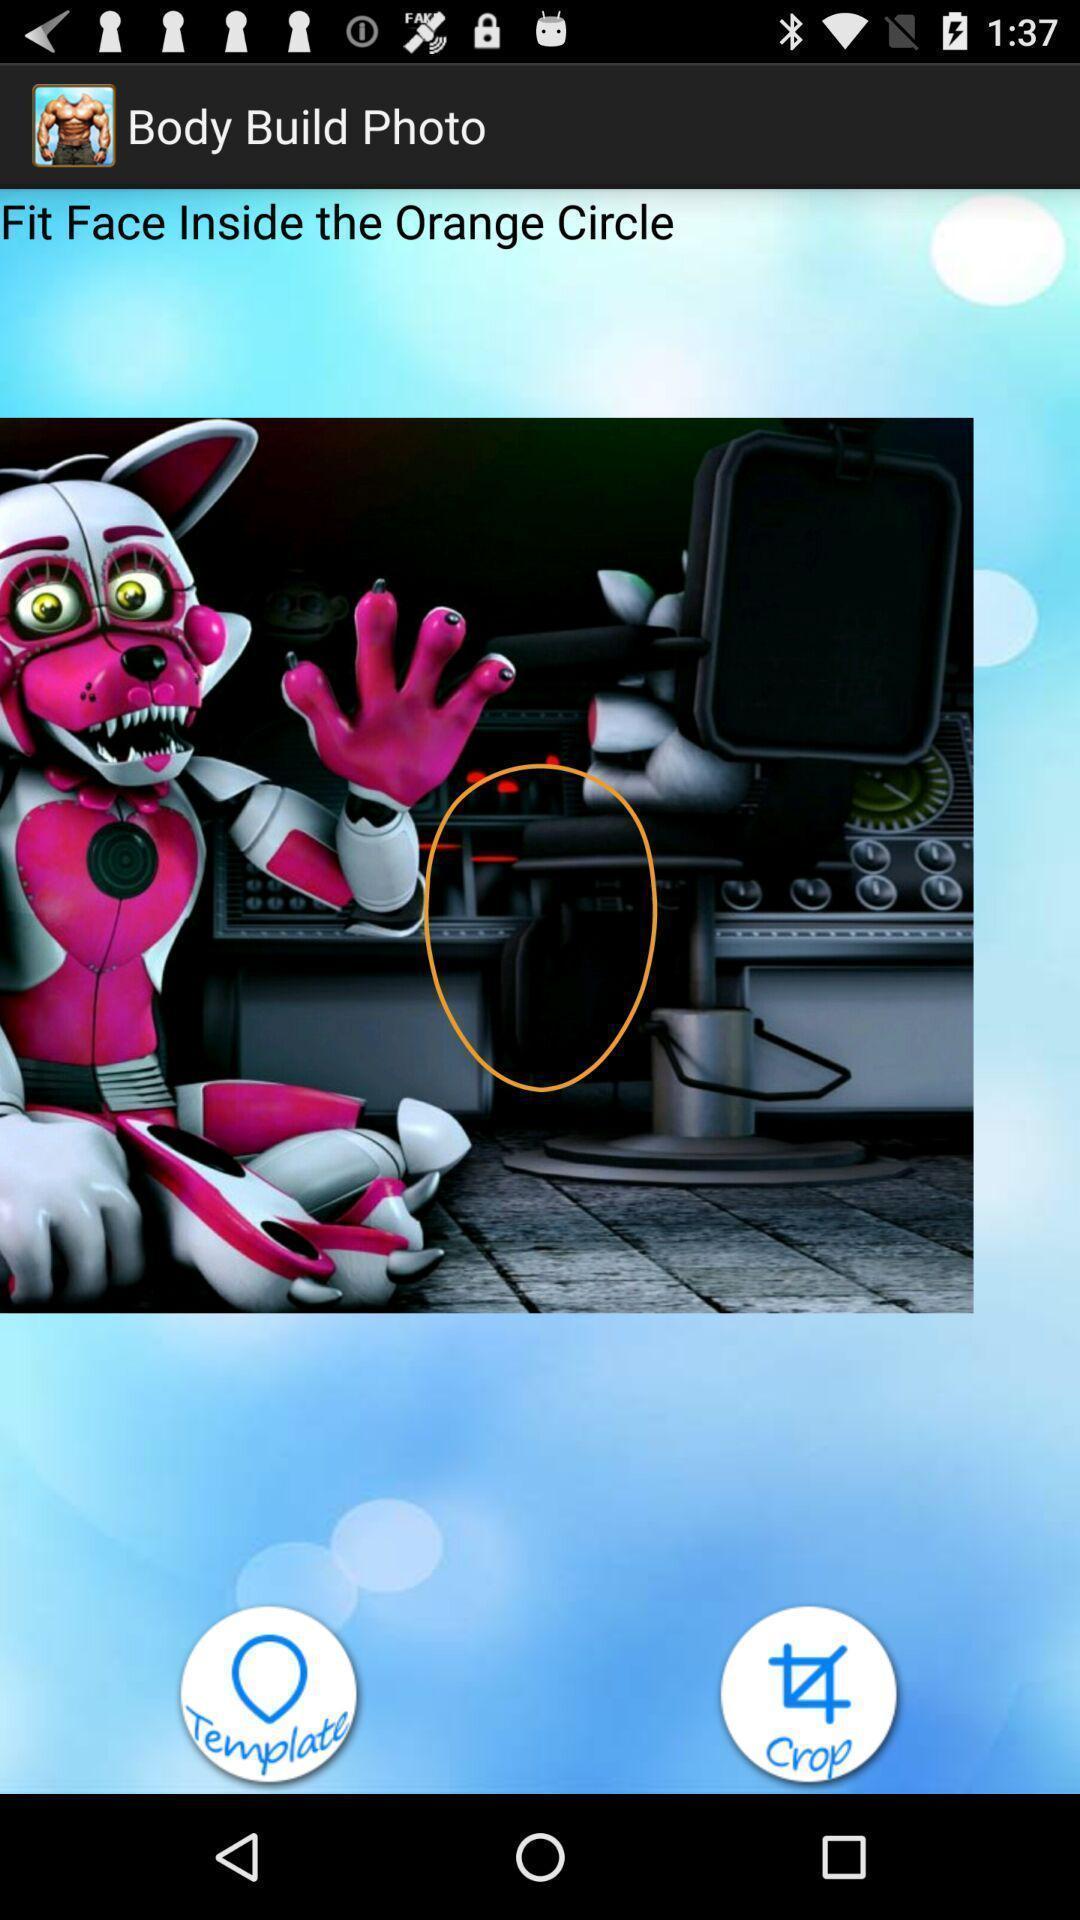Describe the visual elements of this screenshot. Screen shows edit image in a edit app. 